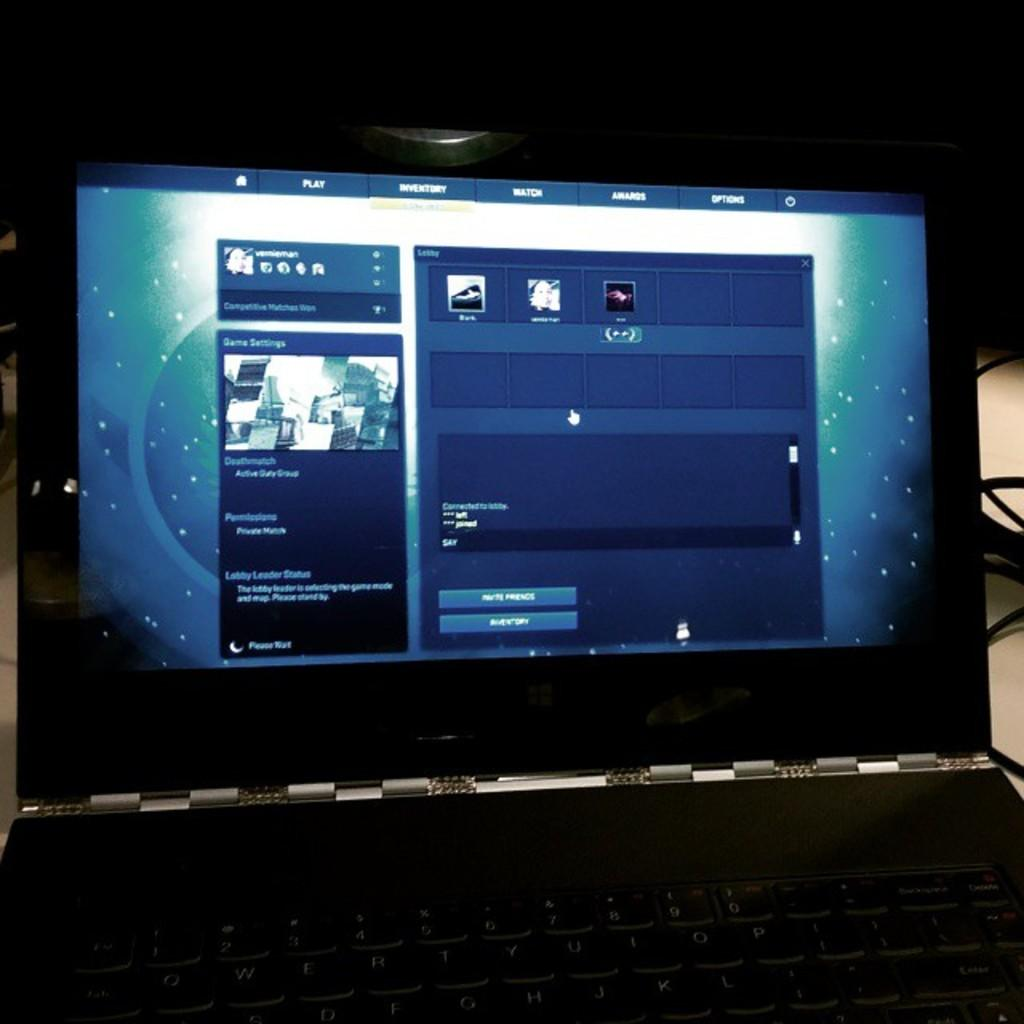What electronic device is visible in the image? There is a laptop screen in the image. What else can be seen in the image besides the laptop screen? There are cables visible in the image. What is the color of the background in the image? The background of the image is dark. What type of industry is depicted in the image? There is no depiction of an industry in the image; it features a laptop screen and cables. What is the limit of the laptop screen in the image? The image does not provide information about the limit of the laptop screen. What is the brick used for in the image? There is no brick present in the image. 